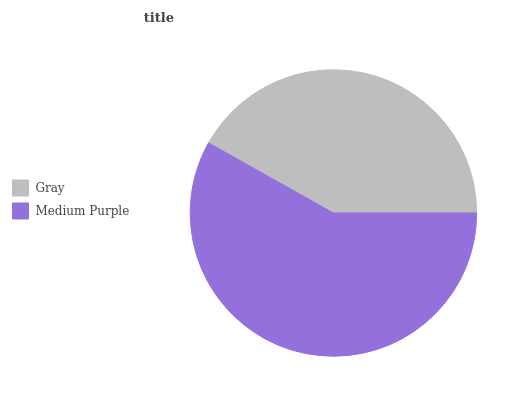Is Gray the minimum?
Answer yes or no. Yes. Is Medium Purple the maximum?
Answer yes or no. Yes. Is Medium Purple the minimum?
Answer yes or no. No. Is Medium Purple greater than Gray?
Answer yes or no. Yes. Is Gray less than Medium Purple?
Answer yes or no. Yes. Is Gray greater than Medium Purple?
Answer yes or no. No. Is Medium Purple less than Gray?
Answer yes or no. No. Is Medium Purple the high median?
Answer yes or no. Yes. Is Gray the low median?
Answer yes or no. Yes. Is Gray the high median?
Answer yes or no. No. Is Medium Purple the low median?
Answer yes or no. No. 